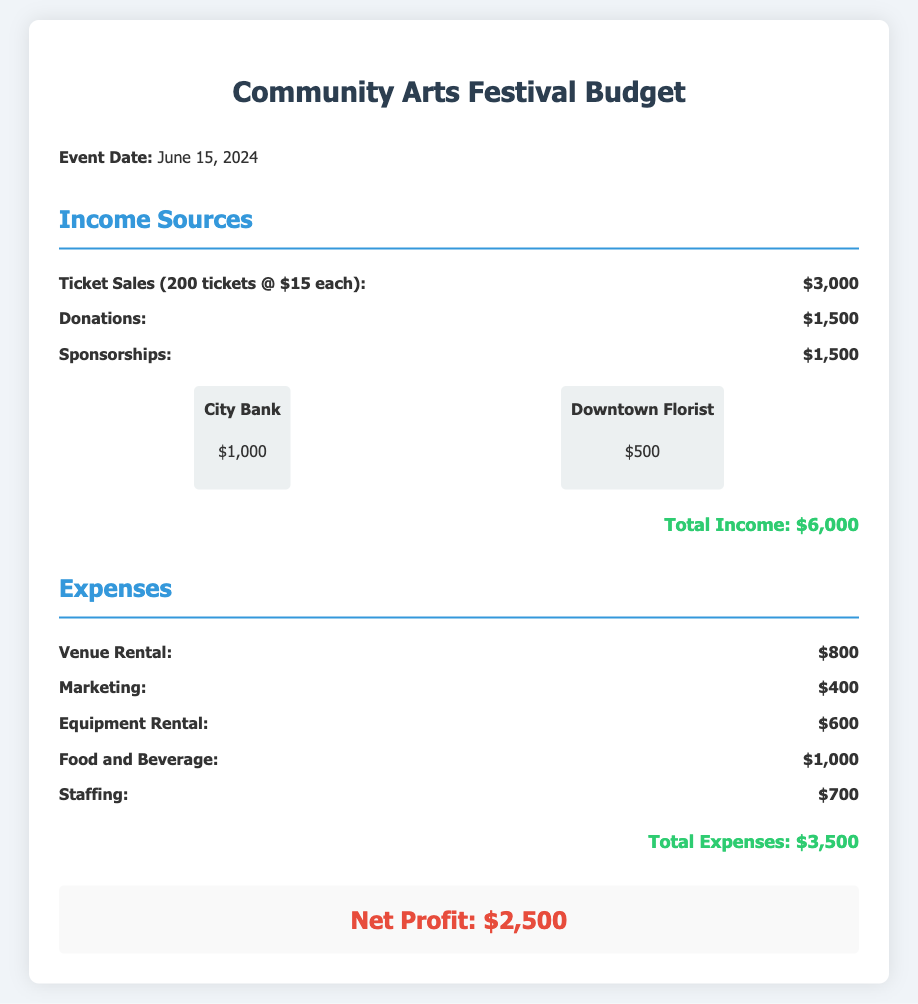What is the event date? The event date is specified in the document under the event details.
Answer: June 15, 2024 What is the total income? The total income is calculated as the sum of all income sources listed in the document.
Answer: $6,000 How many tickets are sold? The number of tickets sold is detailed in the ticket sales item.
Answer: 200 tickets What is the expense for food and beverage? The document lists food and beverage as an expense item along with its cost.
Answer: $1,000 What is the net profit? The net profit is presented at the end of the budget, after calculating total income and expenses.
Answer: $2,500 What is the amount received from donations? The donations income source is specified directly in the budget section.
Answer: $1,500 What is the marketing expense? The document provides a specific cost for marketing under the expenses section.
Answer: $400 Who is the sponsor that contributed $1,000? The document lists sponsors along with their contributions.
Answer: City Bank What is the total expenses? The total expenses are calculated as the sum of all expenses in the document.
Answer: $3,500 